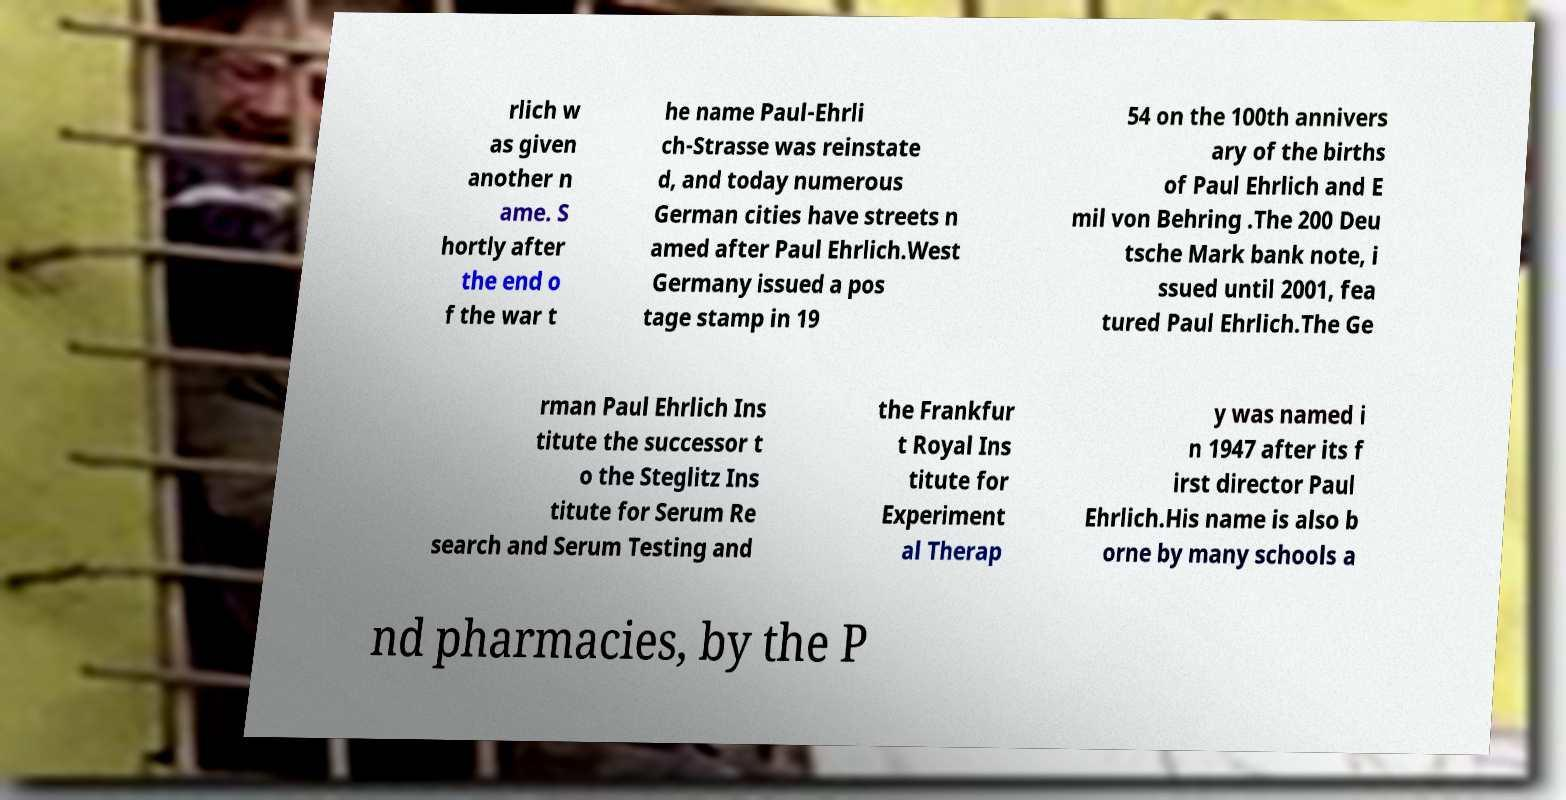Could you assist in decoding the text presented in this image and type it out clearly? rlich w as given another n ame. S hortly after the end o f the war t he name Paul-Ehrli ch-Strasse was reinstate d, and today numerous German cities have streets n amed after Paul Ehrlich.West Germany issued a pos tage stamp in 19 54 on the 100th annivers ary of the births of Paul Ehrlich and E mil von Behring .The 200 Deu tsche Mark bank note, i ssued until 2001, fea tured Paul Ehrlich.The Ge rman Paul Ehrlich Ins titute the successor t o the Steglitz Ins titute for Serum Re search and Serum Testing and the Frankfur t Royal Ins titute for Experiment al Therap y was named i n 1947 after its f irst director Paul Ehrlich.His name is also b orne by many schools a nd pharmacies, by the P 